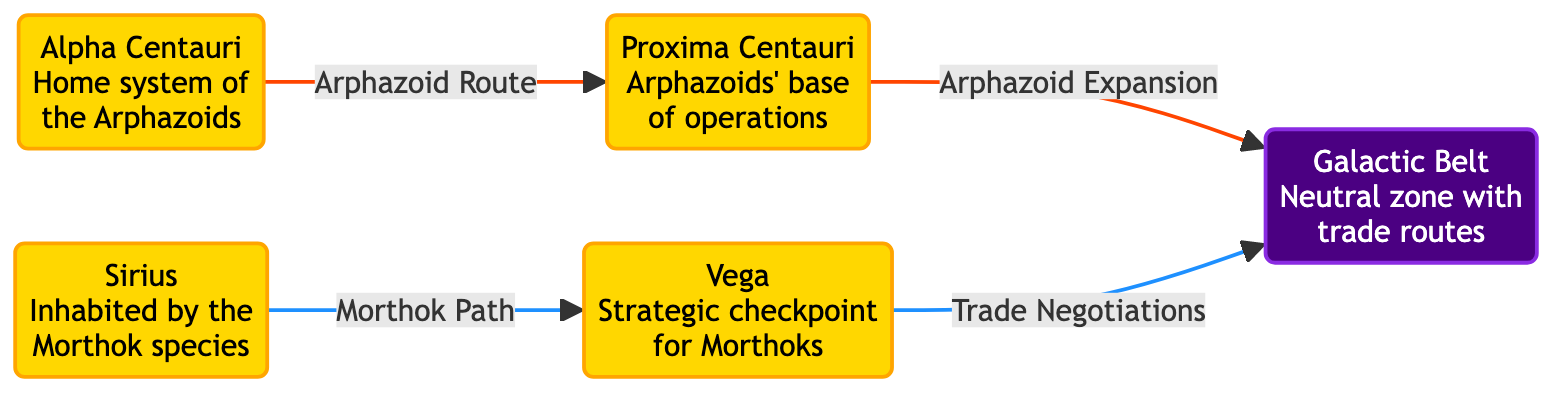What's the home system of the Arphazoids? The diagram specifies that the home system of the Arphazoids is labeled as Alpha Centauri.
Answer: Alpha Centauri How many star systems are represented in the diagram? By counting the star nodes in the diagram, we see Alpha Centauri, Sirius, Proxima Centauri, and Vega, totaling four star systems.
Answer: 4 Which species inhabits Sirius? The diagram indicates that the species inhabiting Sirius is the Morthok species.
Answer: Morthok What is the role of Proxima Centauri in Arphazoid operations? The diagram defines Proxima Centauri as the base of operations for the Arphazoids.
Answer: Base of operations Which star system connects to Vega through trade negotiations? The diagram shows that Galactic Belt connects to Vega through trade negotiations, highlighting an economic interaction between these nodes.
Answer: Galactic Belt Which species uses Vega as a strategic checkpoint? According to the diagram, the Morthok species utilizes Vega as a strategic checkpoint.
Answer: Morthok What connection is labeled as "Arphazoid Expansion"? The diagram reveals that Proxima Centauri is connected to the Galactic Belt, specifically labeled as "Arphazoid Expansion".
Answer: Galactic Belt What color represents the neutral zone with trade routes in the diagram? The diagram indicates that the Galactic Belt is represented in purple, denoting its classification as a neutral zone with trade routes.
Answer: Purple Which routes do the Arphazoids primarily take according to the diagram? The arrows indicate that the Arphazoids primarily traverse from Alpha Centauri to Proxima Centauri and then to the Galactic Belt, signaling their routes.
Answer: Alpha Centauri to Proxima Centauri to Galactic Belt 